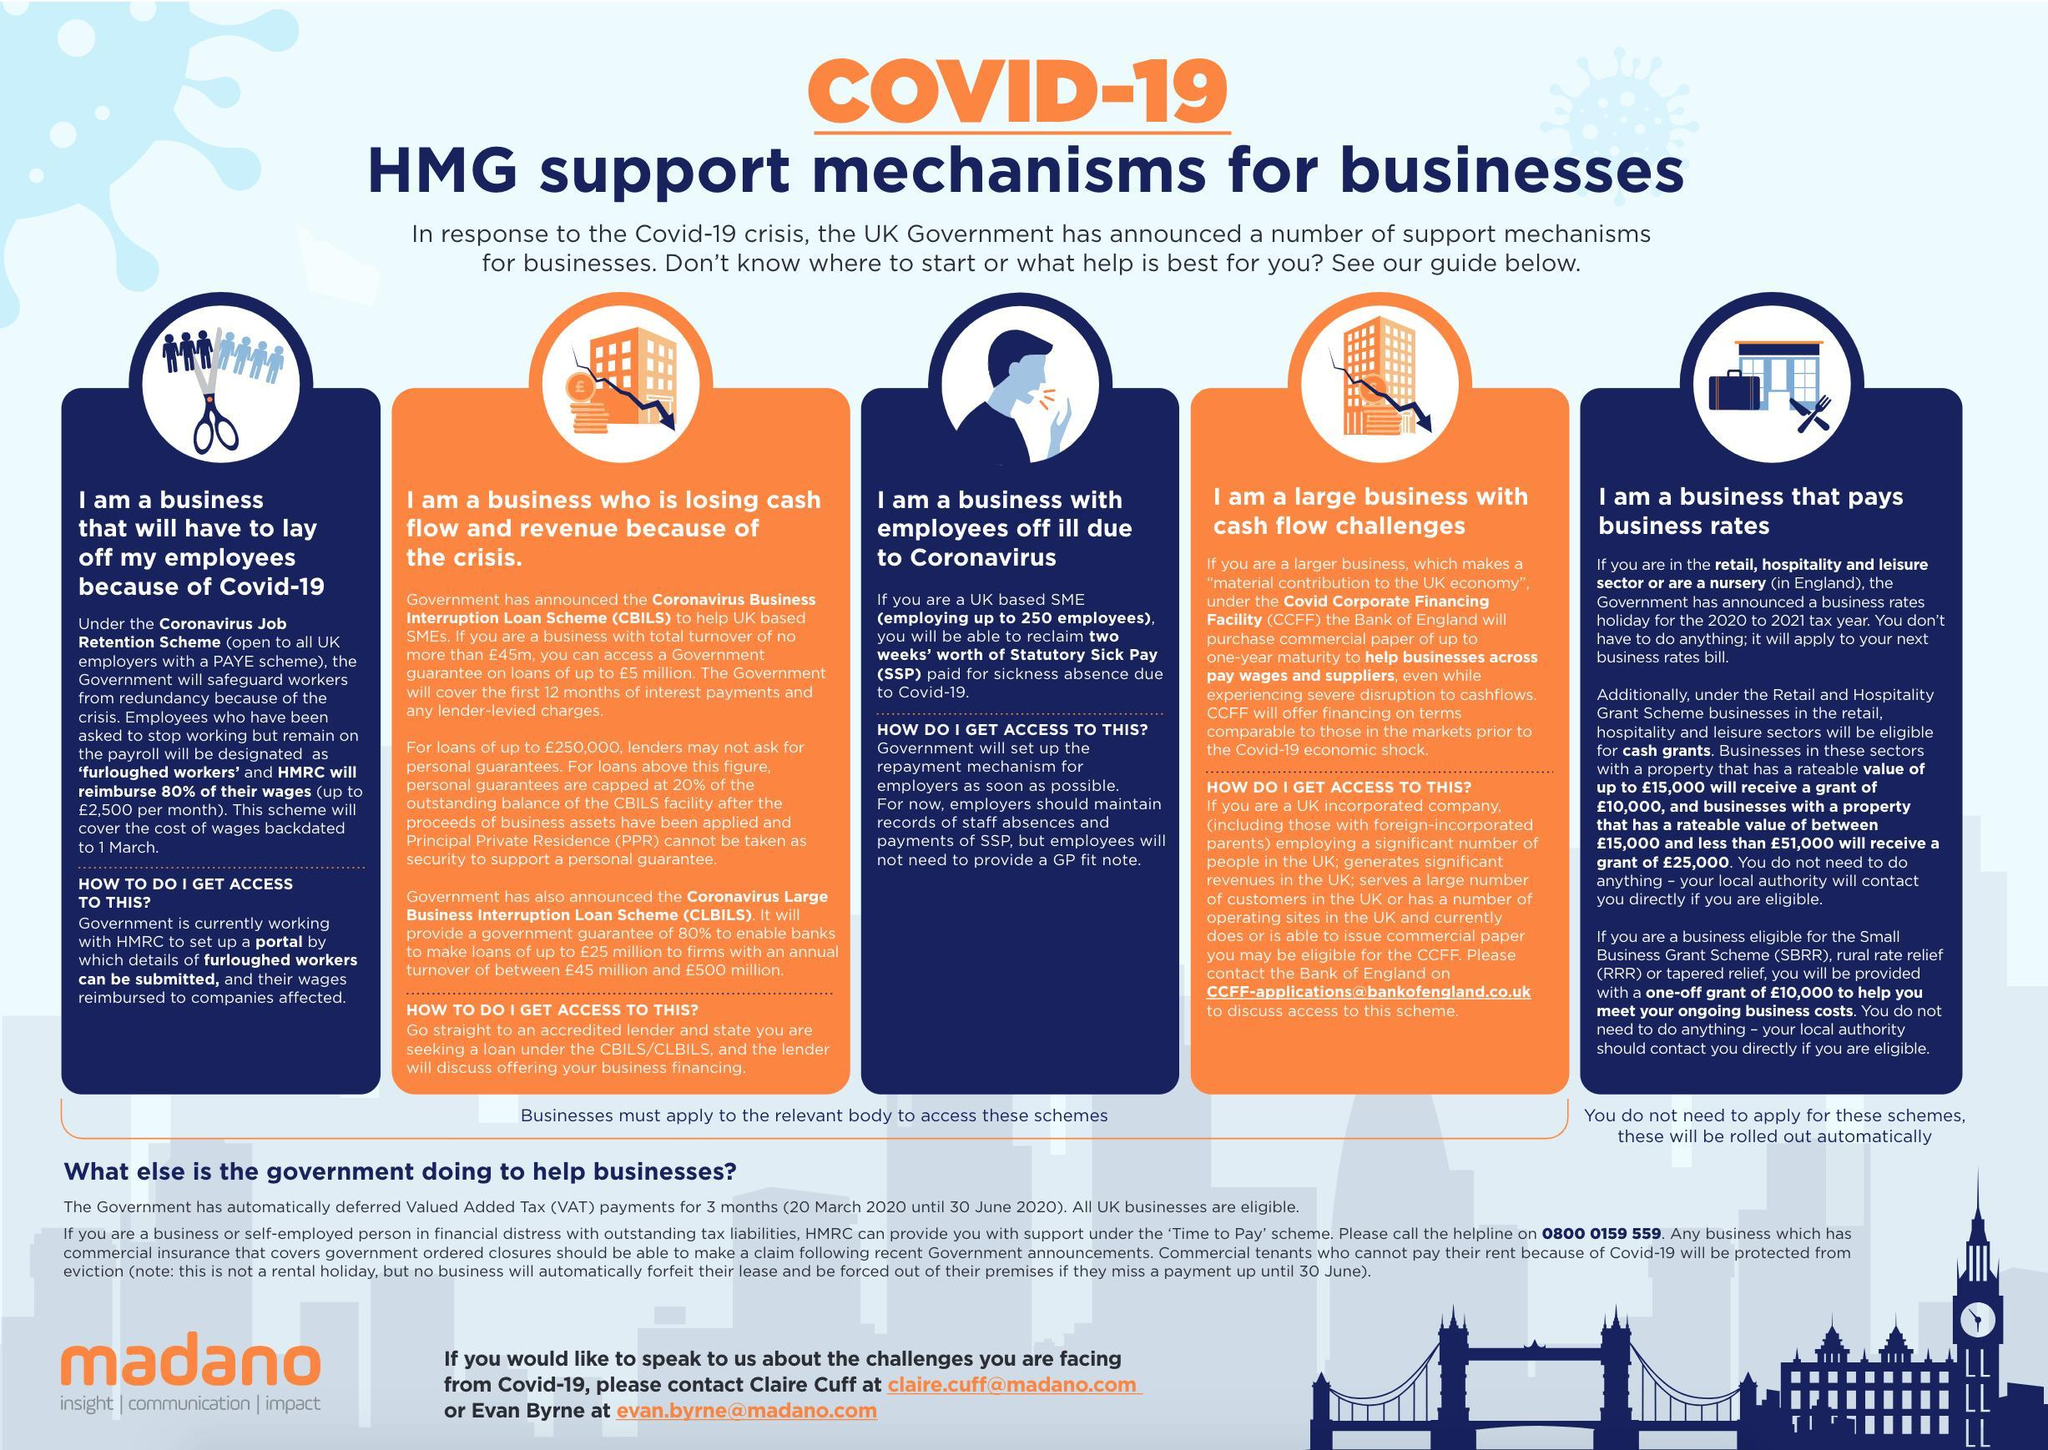what is the employee count of SME
Answer the question with a short phrase. up to  250 for what type of business will the schemes be rolled out automatically business that pays business rates how many types of business has been considered 5 for what type of business is CBILS business who is losing cash flow and revenue because of the crisis for what type of business is the CCFF large business with cash flow challenges for whom is the Coronavirus job retention scheme all UK employers with a PAYE scheme 